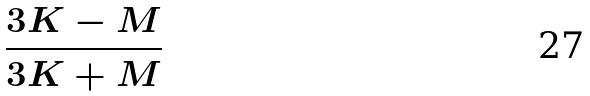Convert formula to latex. <formula><loc_0><loc_0><loc_500><loc_500>\frac { 3 K - M } { 3 K + M }</formula> 